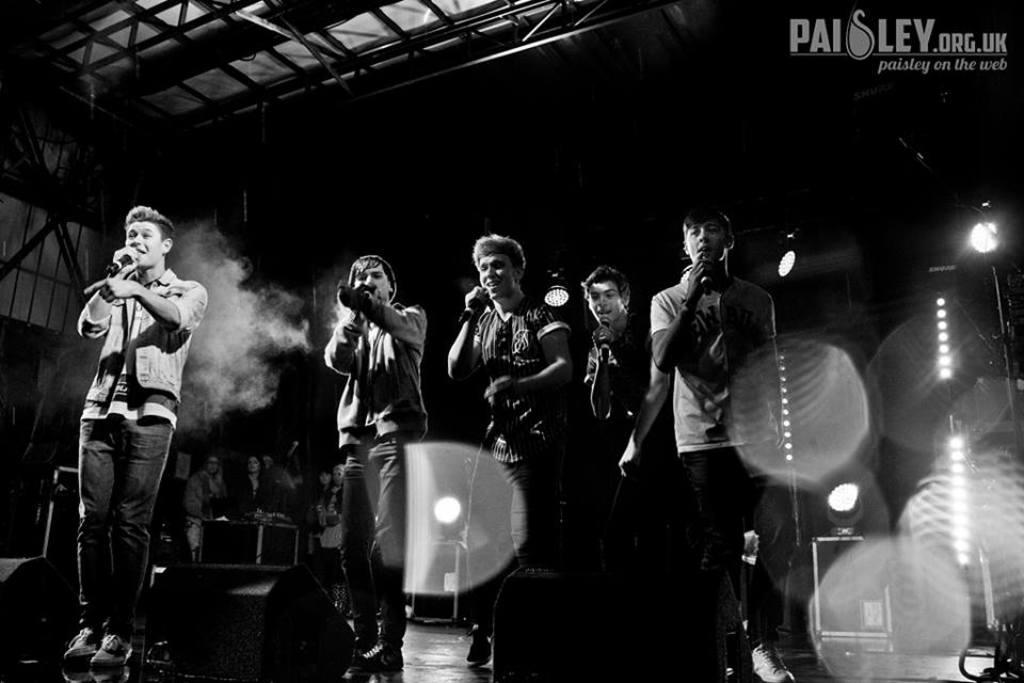What is the main activity of the people in the image? The people in the image are singing. What objects are the people holding in their hands? The people are holding microphones in their hands. Can you describe the distance between the group of people and the person speaking? There is a significant distance between the group of people and the person speaking. What type of lighting is visible in the image? There are focusing lights visible at the top of the image. What type of liquid is being poured from the drawer in the image? There is no liquid or drawer present in the image. 